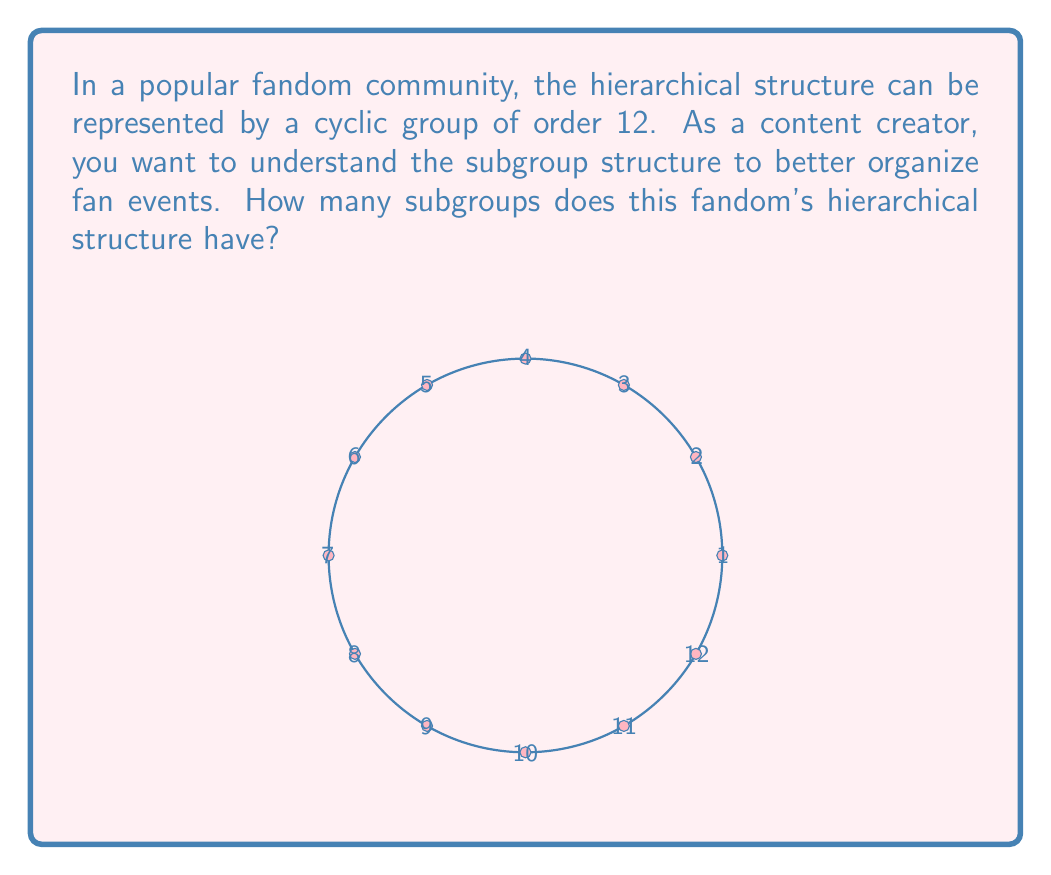Provide a solution to this math problem. To find the number of subgroups in a cyclic group of order 12, we can follow these steps:

1) First, recall that the subgroups of a cyclic group correspond to the divisors of the group's order. The order of our group is 12.

2) Find the divisors of 12:
   $$\text{Divisors of 12} = \{1, 2, 3, 4, 6, 12\}$$

3) For each divisor $d$, there is exactly one subgroup of order $d$. This is because a cyclic group has a unique subgroup for each divisor of its order.

4) Therefore, the number of subgroups is equal to the number of divisors of 12.

5) Count the divisors:
   $$|\{1, 2, 3, 4, 6, 12\}| = 6$$

Thus, the cyclic group of order 12 has 6 subgroups, corresponding to the 6 divisors of 12.
Answer: 6 